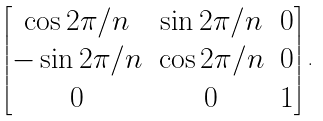Convert formula to latex. <formula><loc_0><loc_0><loc_500><loc_500>\begin{bmatrix} \cos 2 \pi / n & \sin 2 \pi / n & 0 \\ - \sin 2 \pi / n & \cos 2 \pi / n & 0 \\ 0 & 0 & 1 \end{bmatrix} .</formula> 